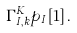<formula> <loc_0><loc_0><loc_500><loc_500>\Gamma ^ { K } _ { I , k } p _ { I } [ 1 ] \, .</formula> 